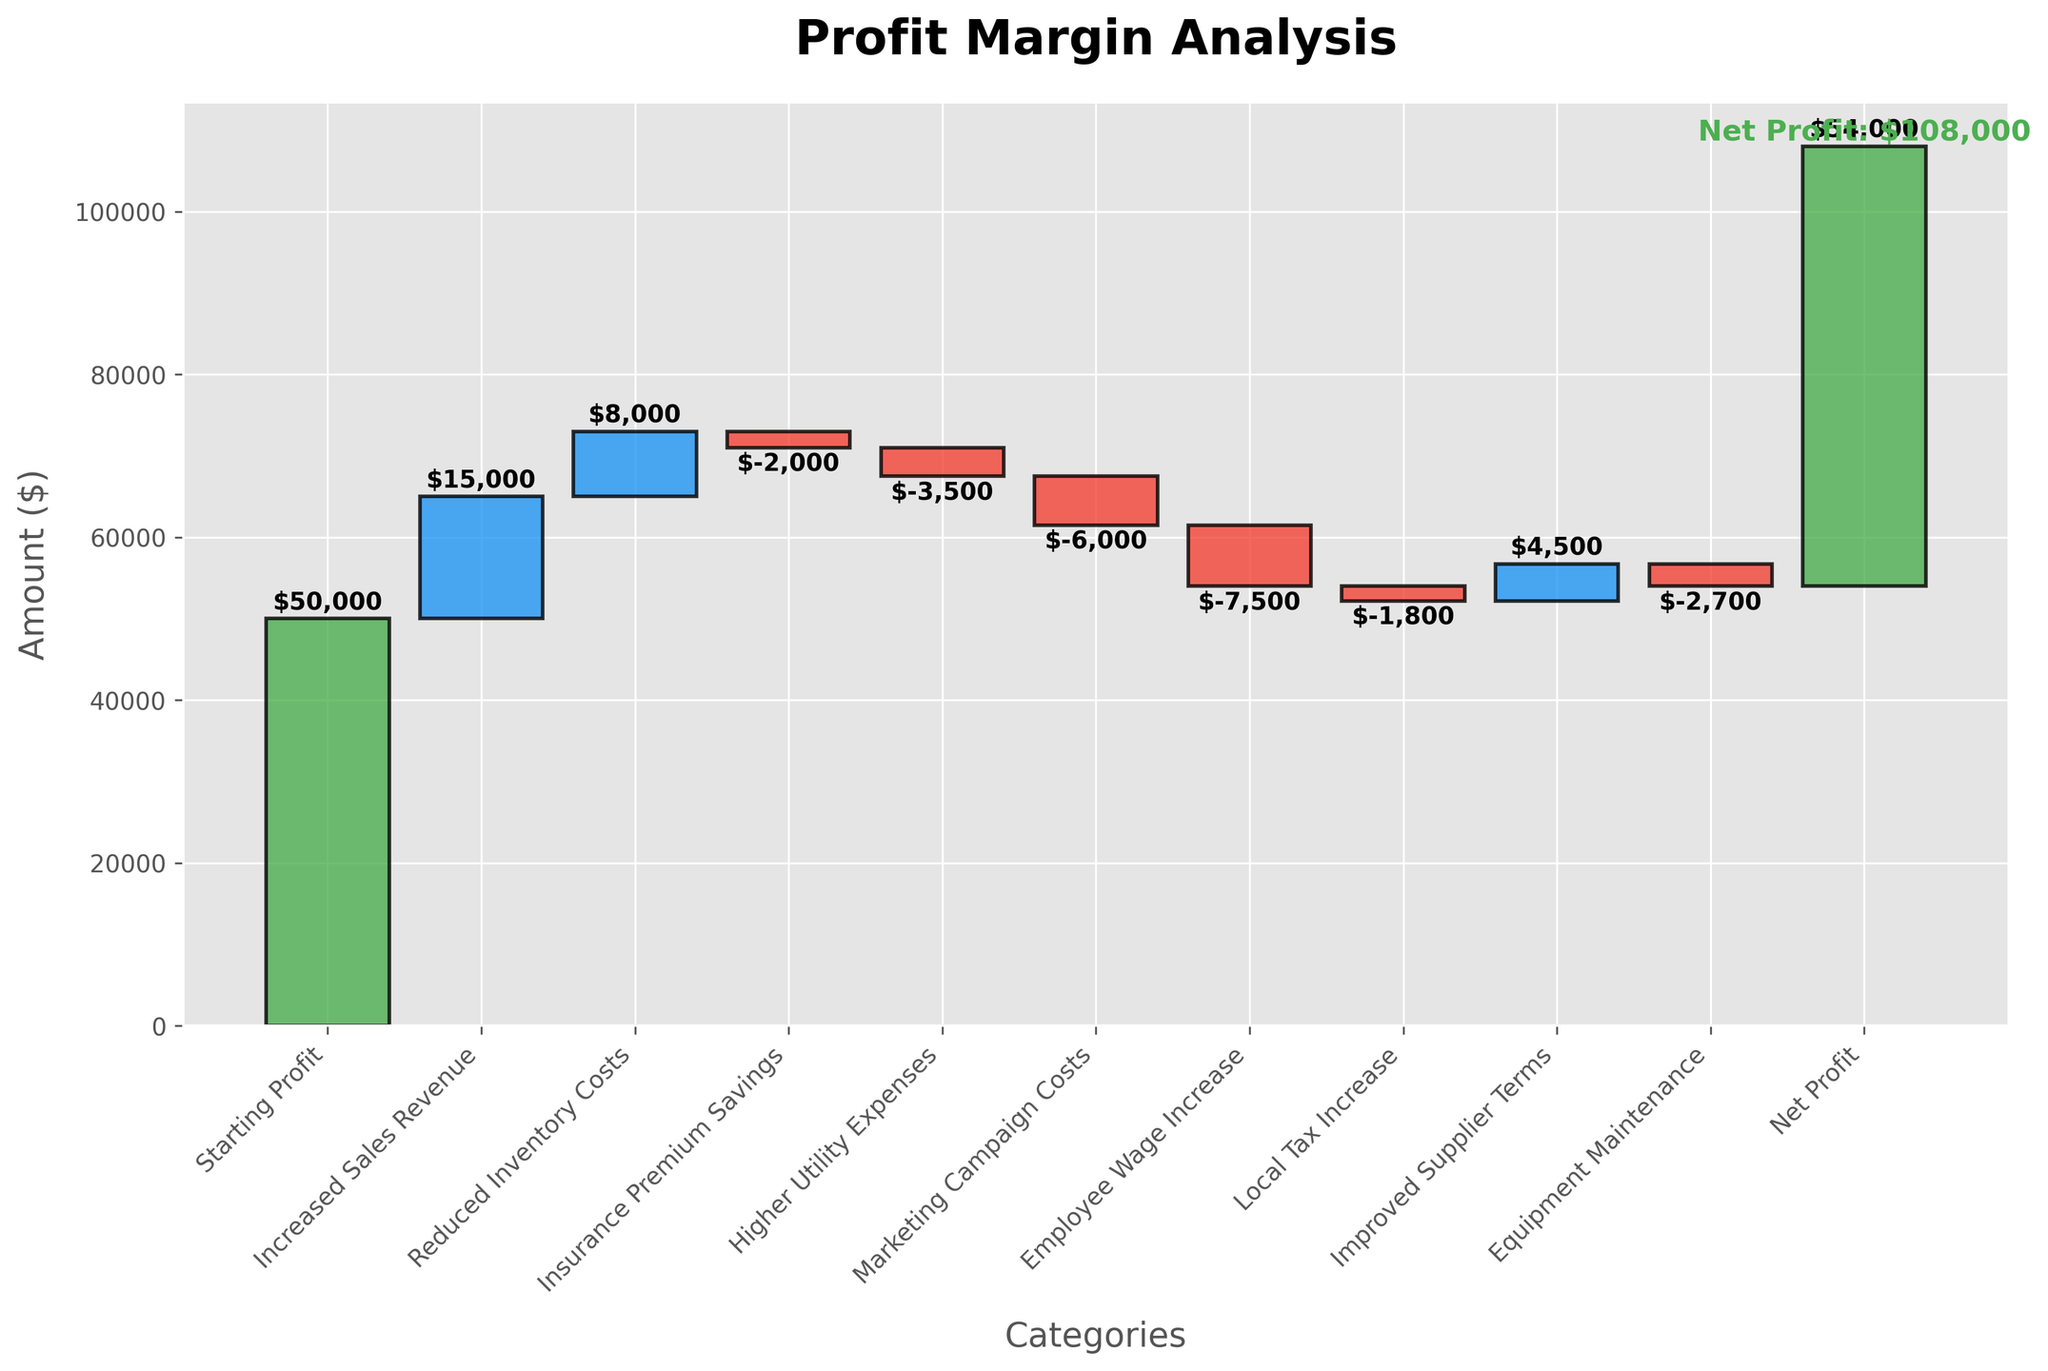What's the starting profit shown in the chart? The starting profit is represented by the first bar in the chart, which is green, indicating the initial profit value.
Answer: $50,000 What is the net profit according to the chart? The net profit is represented by the last bar in the chart, which is again green, indicating the final profit value.
Answer: $54,000 How much did the increased sales revenue contribute to the profit? The contribution from increased sales revenue is represented by the second bar, which is blue for a positive amount.
Answer: $15,000 What is the total amount contributed by reduced inventory costs and insurance premium savings? The amounts for reduced inventory costs and insurance premium savings are 8,000 and -2,000, respectively. Adding them together: 8,000 + (-2,000) = 6,000.
Answer: $6,000 Which category had the highest negative impact on the profit? The category with the highest negative impact is identified by the red bar with the largest magnitude.
Answer: Employee Wage Increase What is the cumulative profit after taking into account marketing campaign costs? Starting from the initial profit of $50,000, add increased sales revenue (+15,000) and reduced inventory costs (+8,000), then subtract insurance premium savings (-2,000) and higher utility expenses (-3,500). Finally, subtract marketing campaign costs (-6,000). Calculation: 50,000 + 15,000 + 8,000 - 2,000 - 3,500 - 6,000 = 61,500.
Answer: $61,500 How much did improved supplier terms improve the profit? The amount contributed by improved supplier terms is represented by one of the blue bars.
Answer: $4,500 Compare the impact of higher utility expenses and equipment maintenance on the profit. Both are represented by red bars indicating negative impacts. Higher utility expenses are -3,500 and equipment maintenance is -2,700.
Answer: Higher Utility Expenses (-$3,500) have a greater negative impact than Equipment Maintenance (-$2,700) By how much did the net profit increase from the starting profit? Calculate the difference between the starting profit and net profit: 54,000 - 50,000 = 4,000.
Answer: $4,000 What happened to the profit when local tax increased? Look at the corresponding red bar for local tax increase to determine the impact.
Answer: The profit decreased by $1,800 